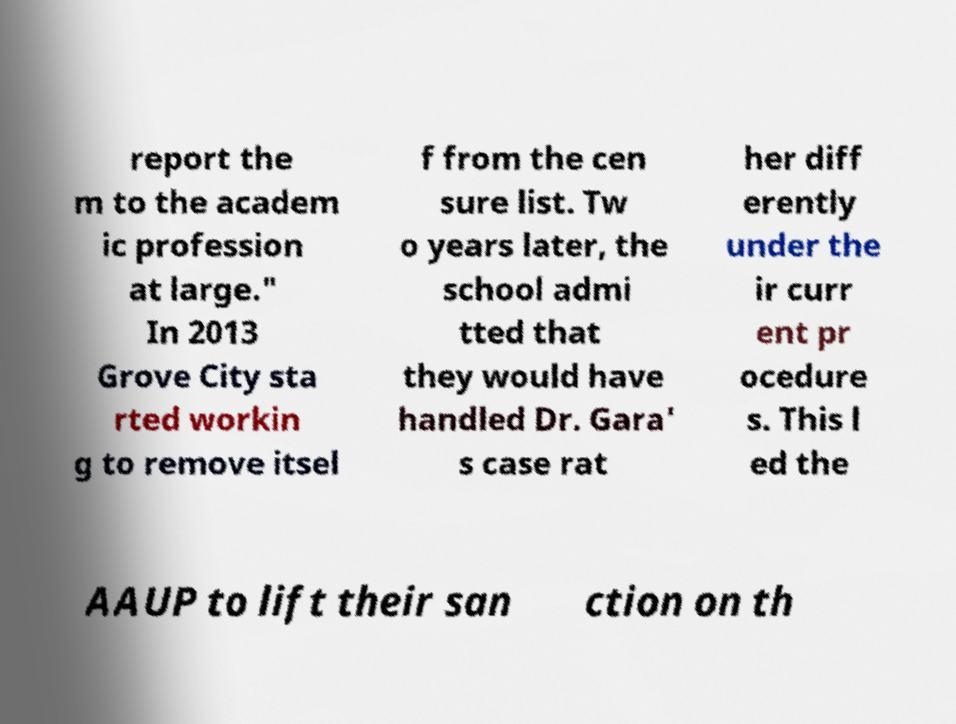Could you extract and type out the text from this image? report the m to the academ ic profession at large." In 2013 Grove City sta rted workin g to remove itsel f from the cen sure list. Tw o years later, the school admi tted that they would have handled Dr. Gara' s case rat her diff erently under the ir curr ent pr ocedure s. This l ed the AAUP to lift their san ction on th 